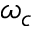<formula> <loc_0><loc_0><loc_500><loc_500>\omega _ { c }</formula> 